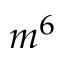<formula> <loc_0><loc_0><loc_500><loc_500>m ^ { 6 }</formula> 